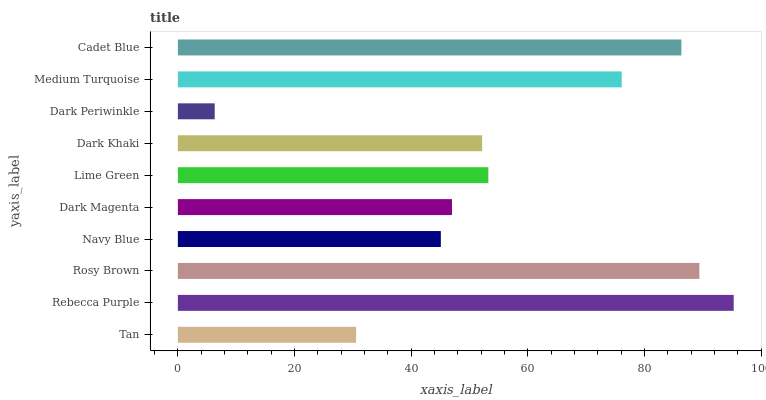Is Dark Periwinkle the minimum?
Answer yes or no. Yes. Is Rebecca Purple the maximum?
Answer yes or no. Yes. Is Rosy Brown the minimum?
Answer yes or no. No. Is Rosy Brown the maximum?
Answer yes or no. No. Is Rebecca Purple greater than Rosy Brown?
Answer yes or no. Yes. Is Rosy Brown less than Rebecca Purple?
Answer yes or no. Yes. Is Rosy Brown greater than Rebecca Purple?
Answer yes or no. No. Is Rebecca Purple less than Rosy Brown?
Answer yes or no. No. Is Lime Green the high median?
Answer yes or no. Yes. Is Dark Khaki the low median?
Answer yes or no. Yes. Is Dark Khaki the high median?
Answer yes or no. No. Is Rosy Brown the low median?
Answer yes or no. No. 